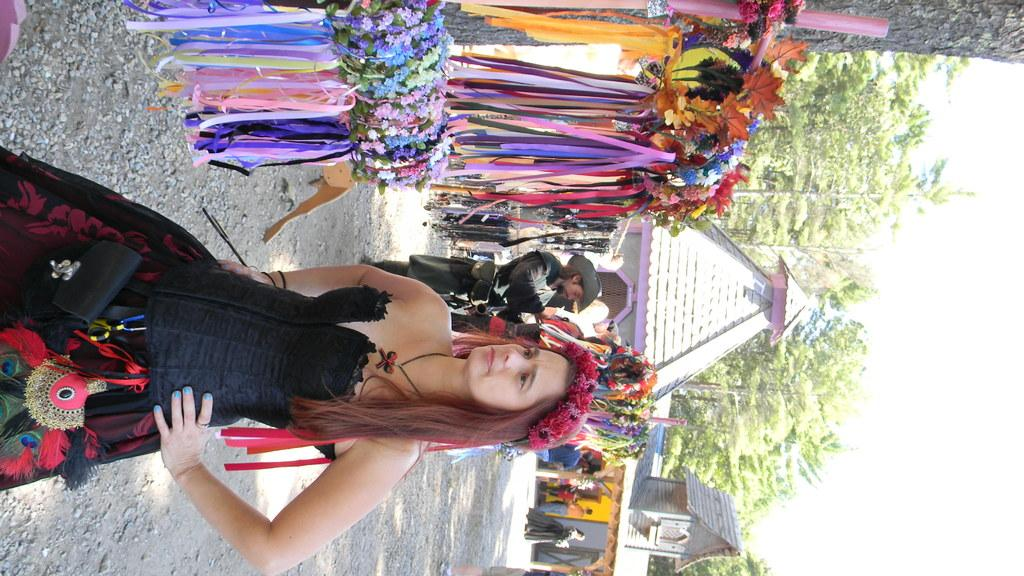What type of structures can be seen in the image? There are houses in the image. What feature can be found on the houses? There are windows in the image. What type of natural elements are present in the image? There are trees in the image. What part of the environment is visible in the image? The sky is visible in the image. Who or what else can be seen in the image? There are people in the image. What distinguishing feature can be observed on the people? There are colorful head-wears in the image. What theory is being discussed by the people in the image? There is no indication in the image that the people are discussing a theory. Can you see any elbows in the image? The image does not show any elbows; it focuses on houses, windows, trees, the sky, people, and colorful head-wears. 